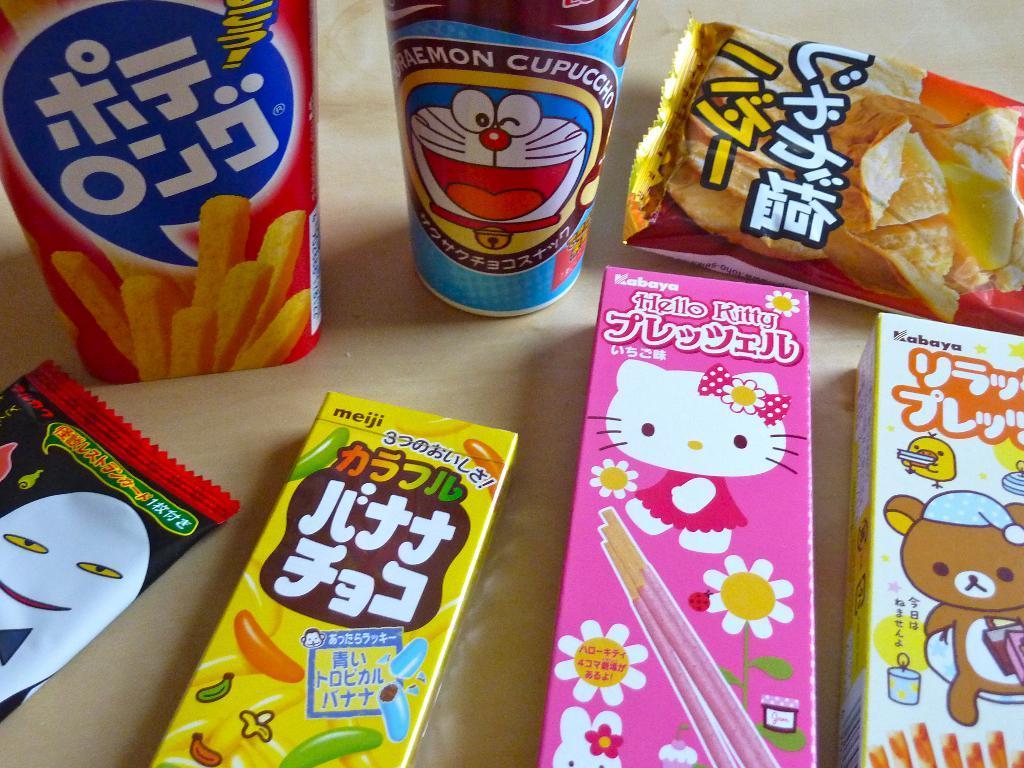Could you give a brief overview of what you see in this image? There are three boxes, two packets and two bottles placed on a table. And the background is cream in color. 